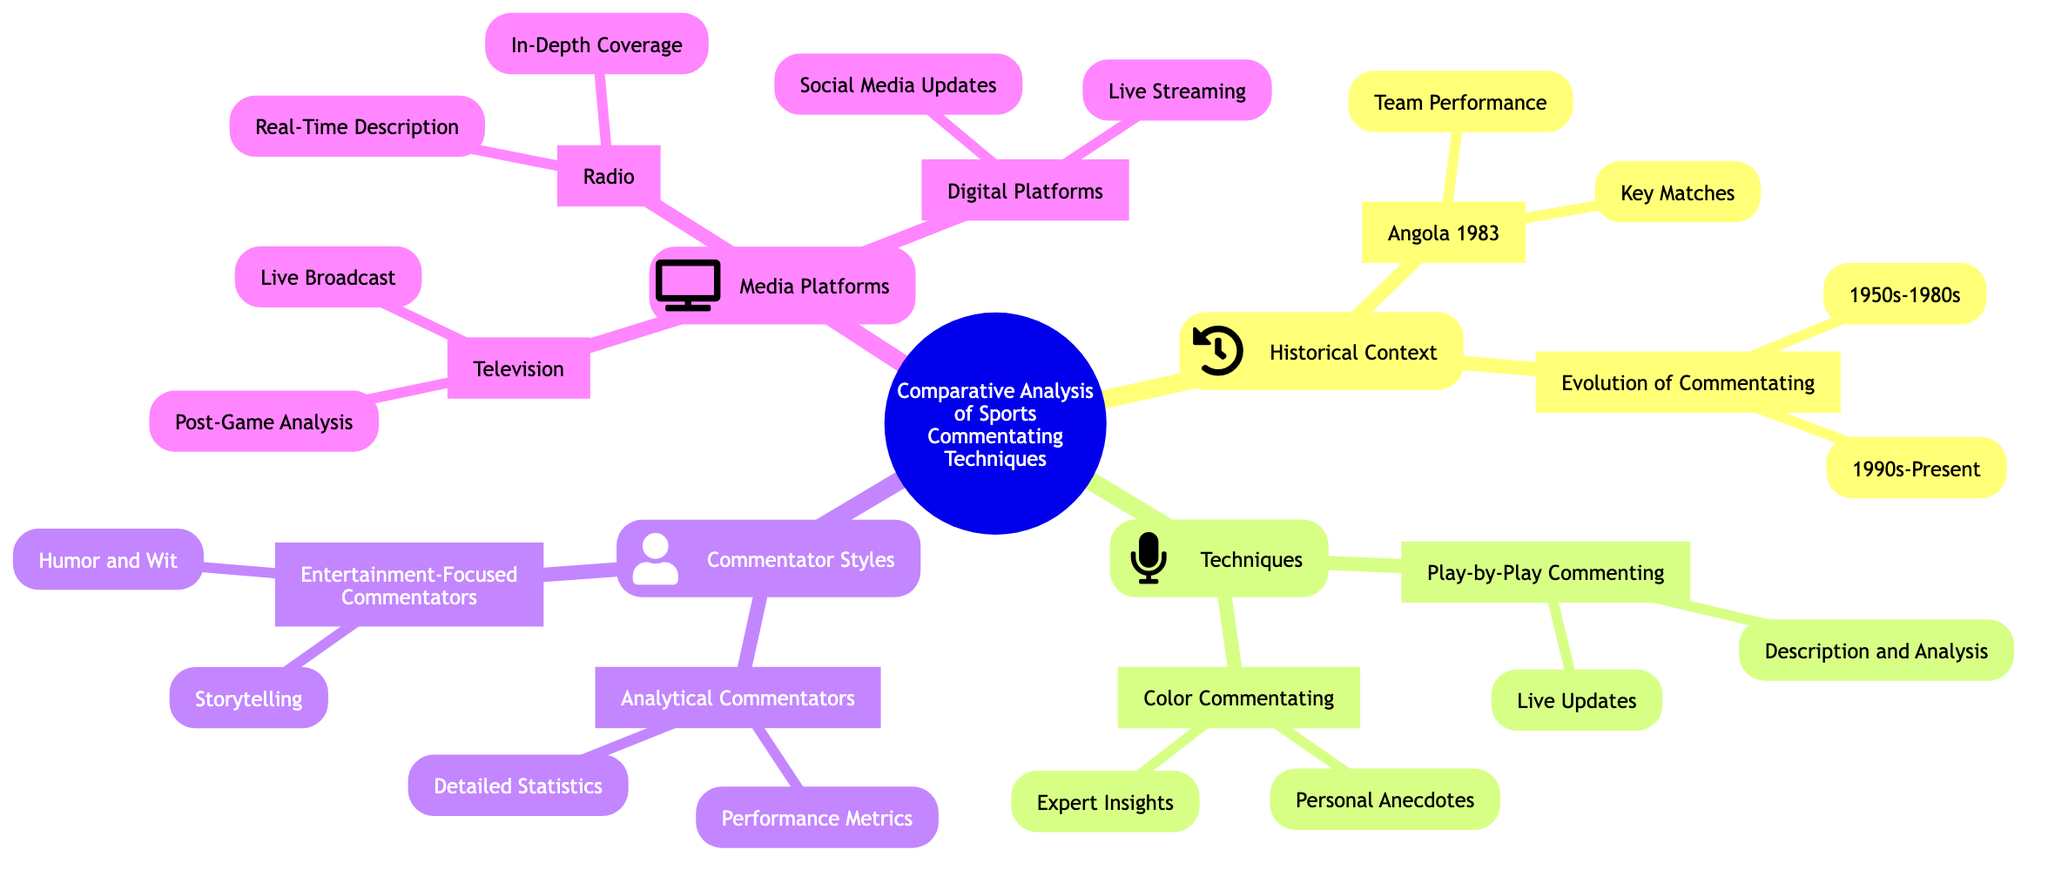What's the central topic of this mind map? The central topic is indicated at the root of the diagram, which focuses on the comparative analysis of sports commentating techniques.
Answer: Comparative Analysis of Sports Commentating Techniques How many sub-branches are under the "Techniques" branch? The "Techniques" branch has two main sub-branches: "Play-by-Play Commenting" and "Color Commentating", totaling two sub-branches.
Answer: 2 What is one key match category listed under "Angola 1983"? The sub-branch under "Angola 1983" includes "Key Matches", which directly answers this question.
Answer: Key Matches Which commentator style focuses on performance metrics? The style that focuses on performance metrics is found under the "Analytical Commentators" sub-branch.
Answer: Analytical Commentators What type of platforms does the "Media Platforms" branch include? The "Media Platforms" branch includes multiple types such as "Television", "Radio", and "Digital Platforms". The question specifically is asking for one of them.
Answer: Television What are the two time periods listed under "Evolution of Commentating"? The two time periods listed are "1950s-1980s" and "1990s-Present", which represent the evolution of commentating styles.
Answer: 1950s-1980s and 1990s-Present What does the "Color Commentating" sub-branch focus on? This sub-branch includes two areas of focus: "Expert Insights" and "Personal Anecdotes", highlighting its emphasis on subjective and entertaining aspects of commentating.
Answer: Expert Insights and Personal Anecdotes Which media platform is associated with "Live Streaming"? "Live Streaming" is specifically listed under the "Digital Platforms" sub-branch, highlighting modern methods of sports commentary distribution.
Answer: Digital Platforms What is a characteristic of "Entertainment-Focused Commentators"? The "Entertainment-Focused Commentators" branch includes "Humor and Wit", indicating their focus on a more engaging and entertaining style of commentating.
Answer: Humor and Wit 